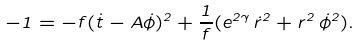Convert formula to latex. <formula><loc_0><loc_0><loc_500><loc_500>- 1 = - f ( \dot { t } - A \dot { \phi } ) ^ { 2 } + \frac { 1 } { f } ( e ^ { 2 \gamma } \, \dot { r } ^ { 2 } + r ^ { 2 } \, \dot { \phi } ^ { 2 } ) .</formula> 